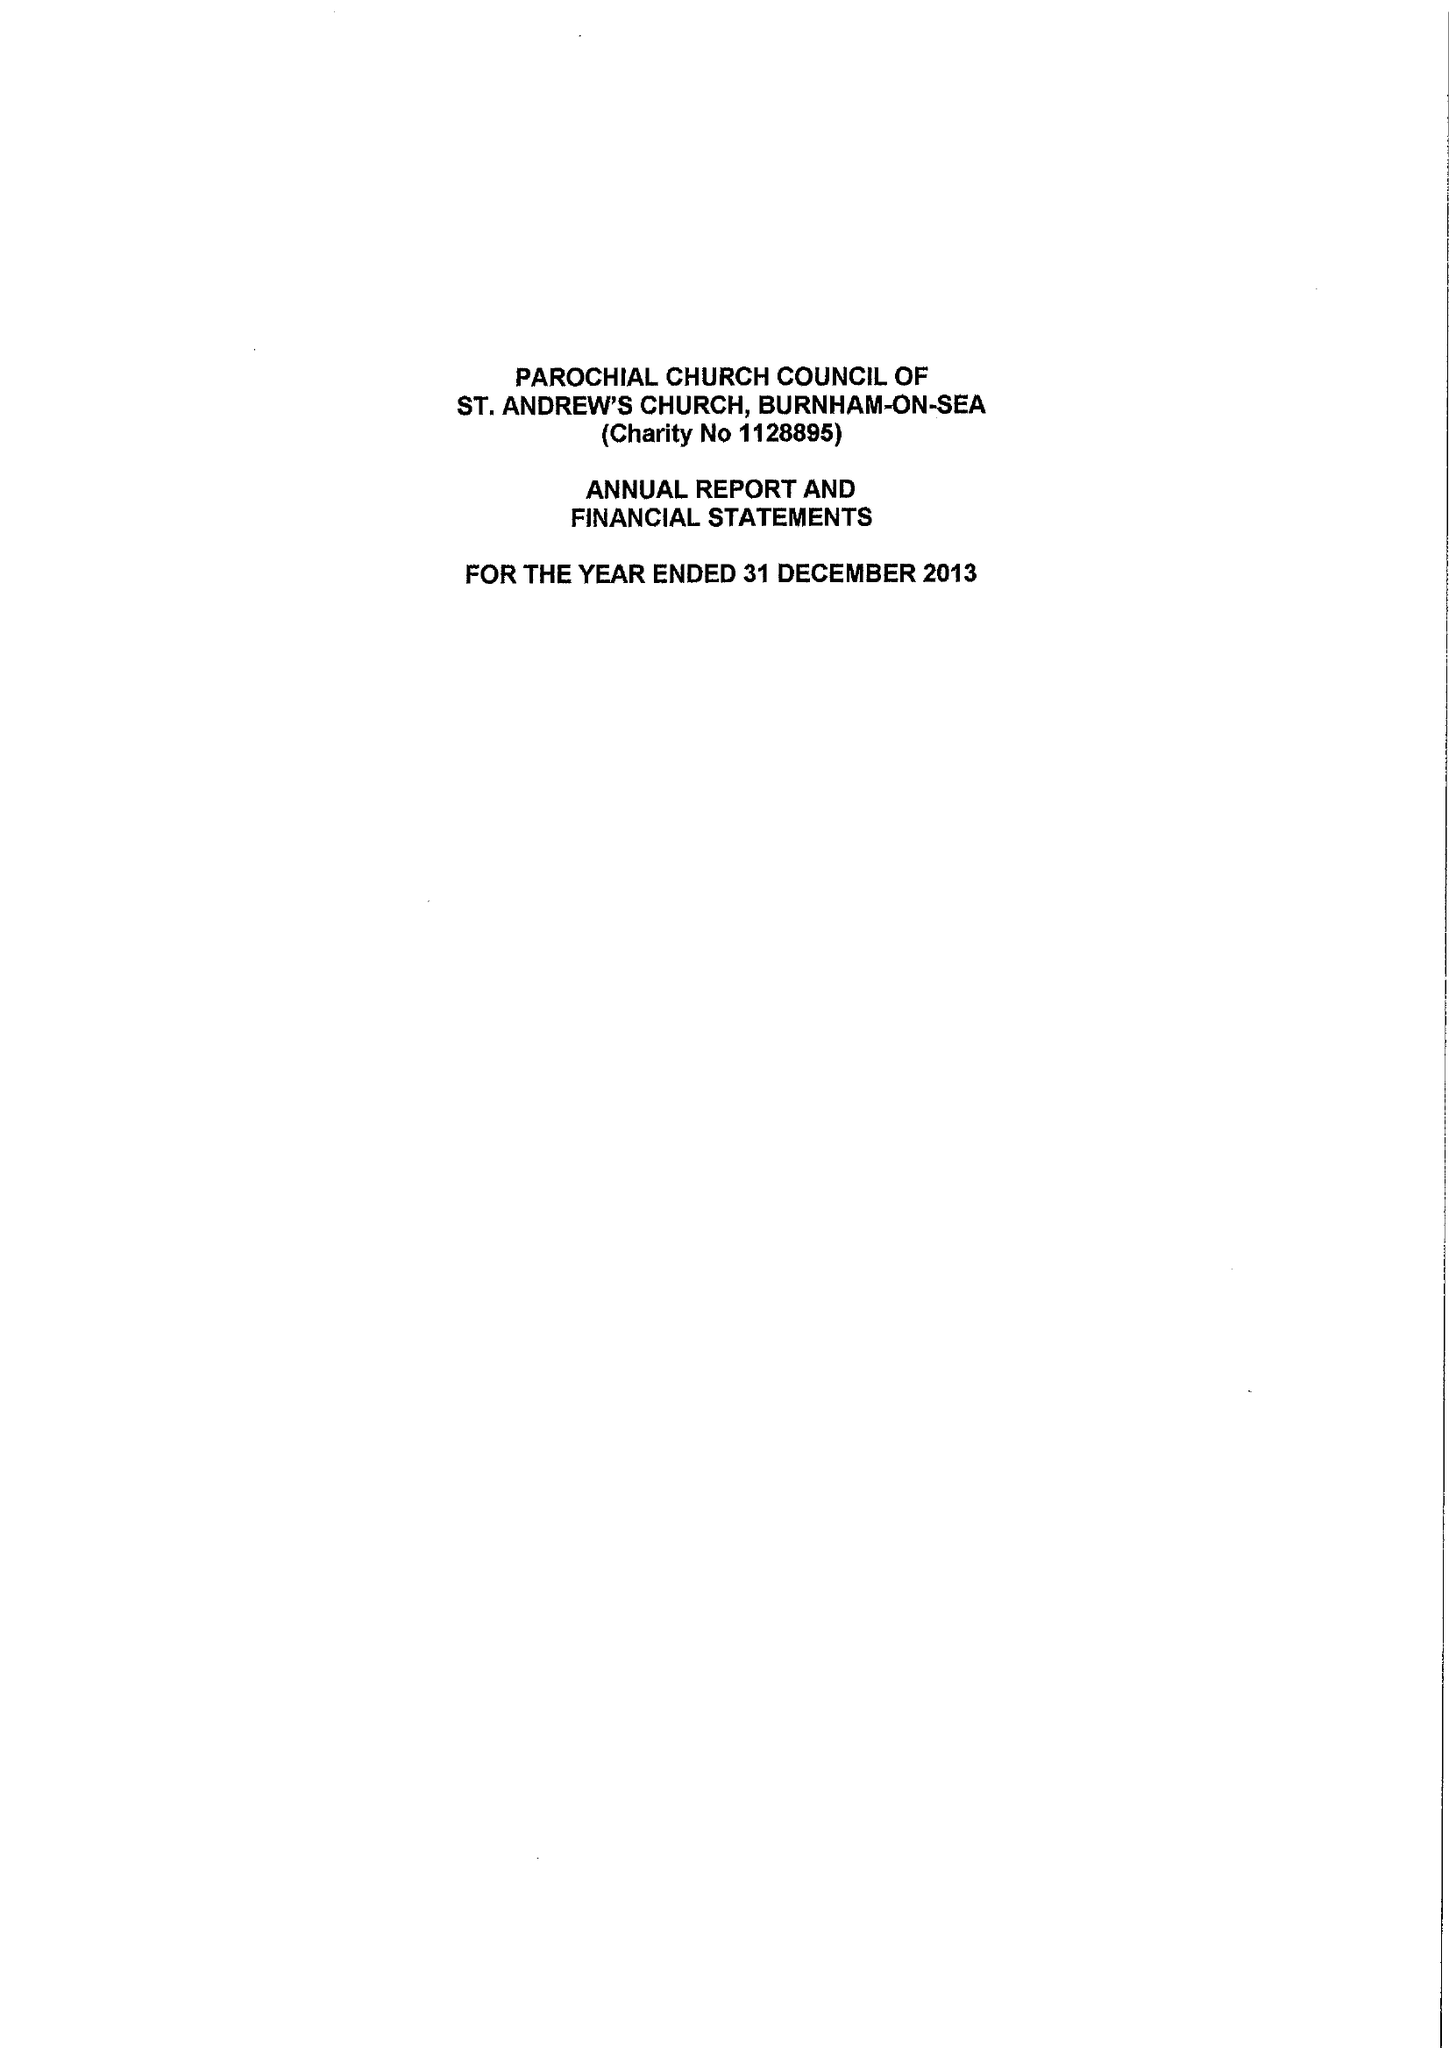What is the value for the income_annually_in_british_pounds?
Answer the question using a single word or phrase. 123673.00 